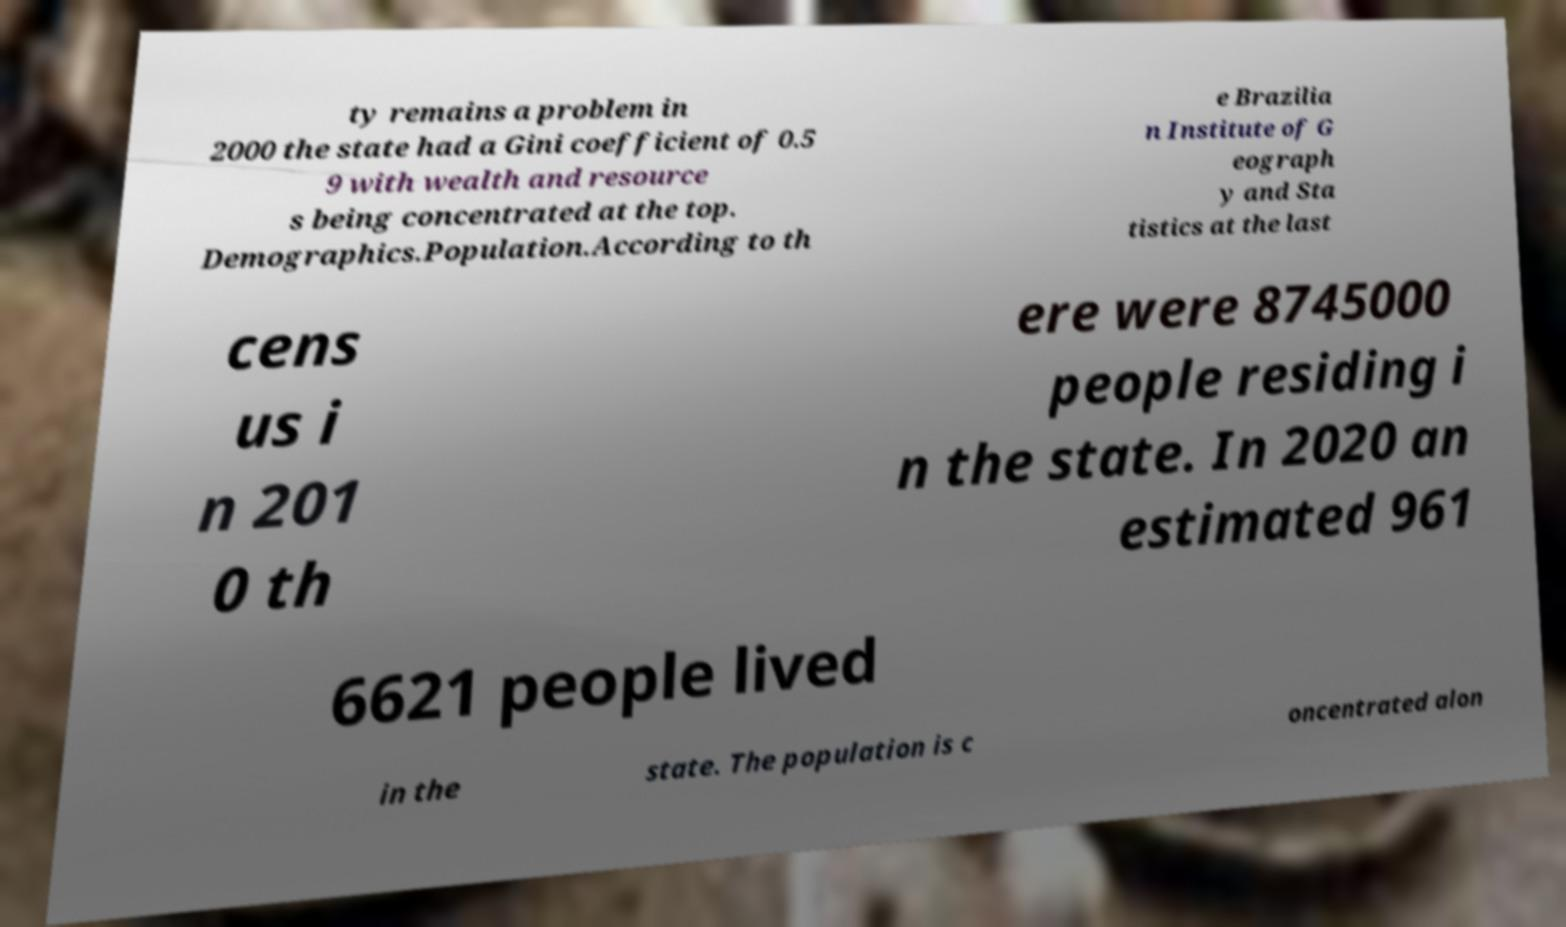Please identify and transcribe the text found in this image. ty remains a problem in 2000 the state had a Gini coefficient of 0.5 9 with wealth and resource s being concentrated at the top. Demographics.Population.According to th e Brazilia n Institute of G eograph y and Sta tistics at the last cens us i n 201 0 th ere were 8745000 people residing i n the state. In 2020 an estimated 961 6621 people lived in the state. The population is c oncentrated alon 